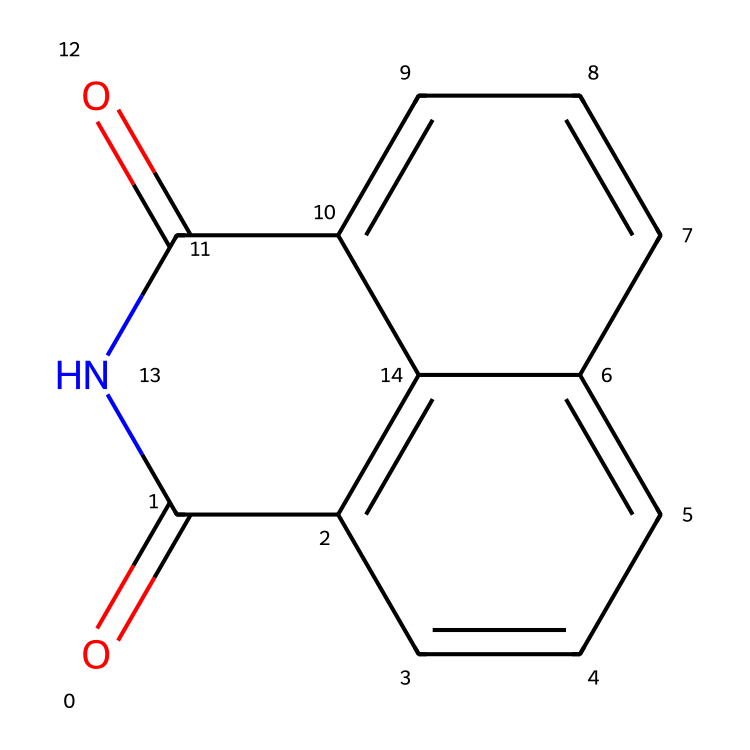What is the main functional group present in naphthalimide? The structure shows a carbonyl group (C=O) linked to a nitrogen atom (N), which represents the imide functional group characteristic of naphthalimides.
Answer: imide How many rings are present in the naphthalimide structure? By examining the chemical structure, there are fused aromatic rings numbered in the two naphthalene units, resulting in a total of three fused rings.
Answer: three What is the total number of carbon atoms in naphthalimide? Counting all the carbon atoms in the provided structure, there are a total of 12 carbon atoms visible, including those in both the naphthalene structure and carbonyl groups.
Answer: twelve What type of bonding is primarily found between the carbon atoms in naphthalimide? The structure shows that the carbon atoms are interconnected by double bonds (C=C) in the aromatic rings and single bonds (C-C) elsewhere, indicative of typical aromatic bonding.
Answer: aromatic Is naphthalimide considered a colored dye? The chromophores present in the molecular structure of naphthalimide allow for the absorption of light, resulting in a colored appearance when used in dyes.
Answer: yes What characteristic of the naphthalimide structure contributes to its dye abilities? The balanced structure with extensive conjugation through the fused rings allows for better light absorption, enhancing its ability as a dye.
Answer: conjugation How many nitrogen atoms are in the naphthalimide structure? The skeletal representation shows two nitrogen atoms in the naphthalimide structure, confirming the presence of an imide functional group.
Answer: two 